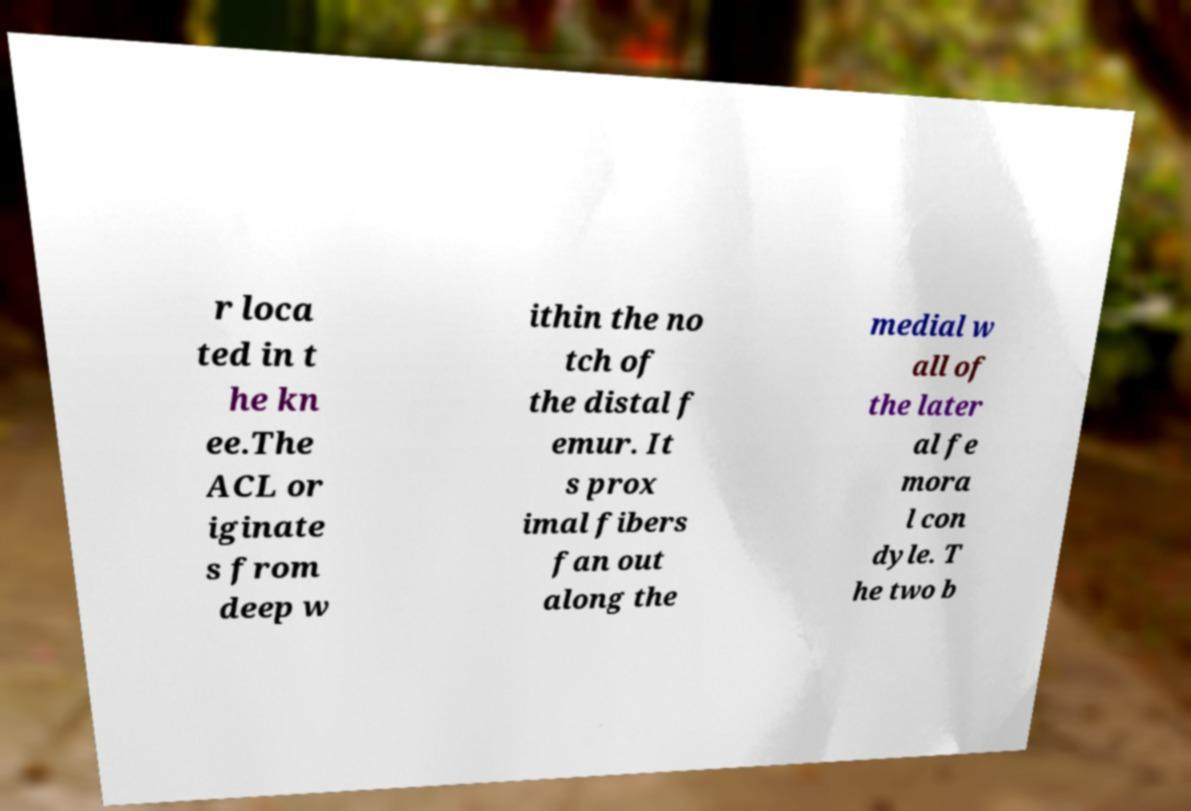Please identify and transcribe the text found in this image. r loca ted in t he kn ee.The ACL or iginate s from deep w ithin the no tch of the distal f emur. It s prox imal fibers fan out along the medial w all of the later al fe mora l con dyle. T he two b 